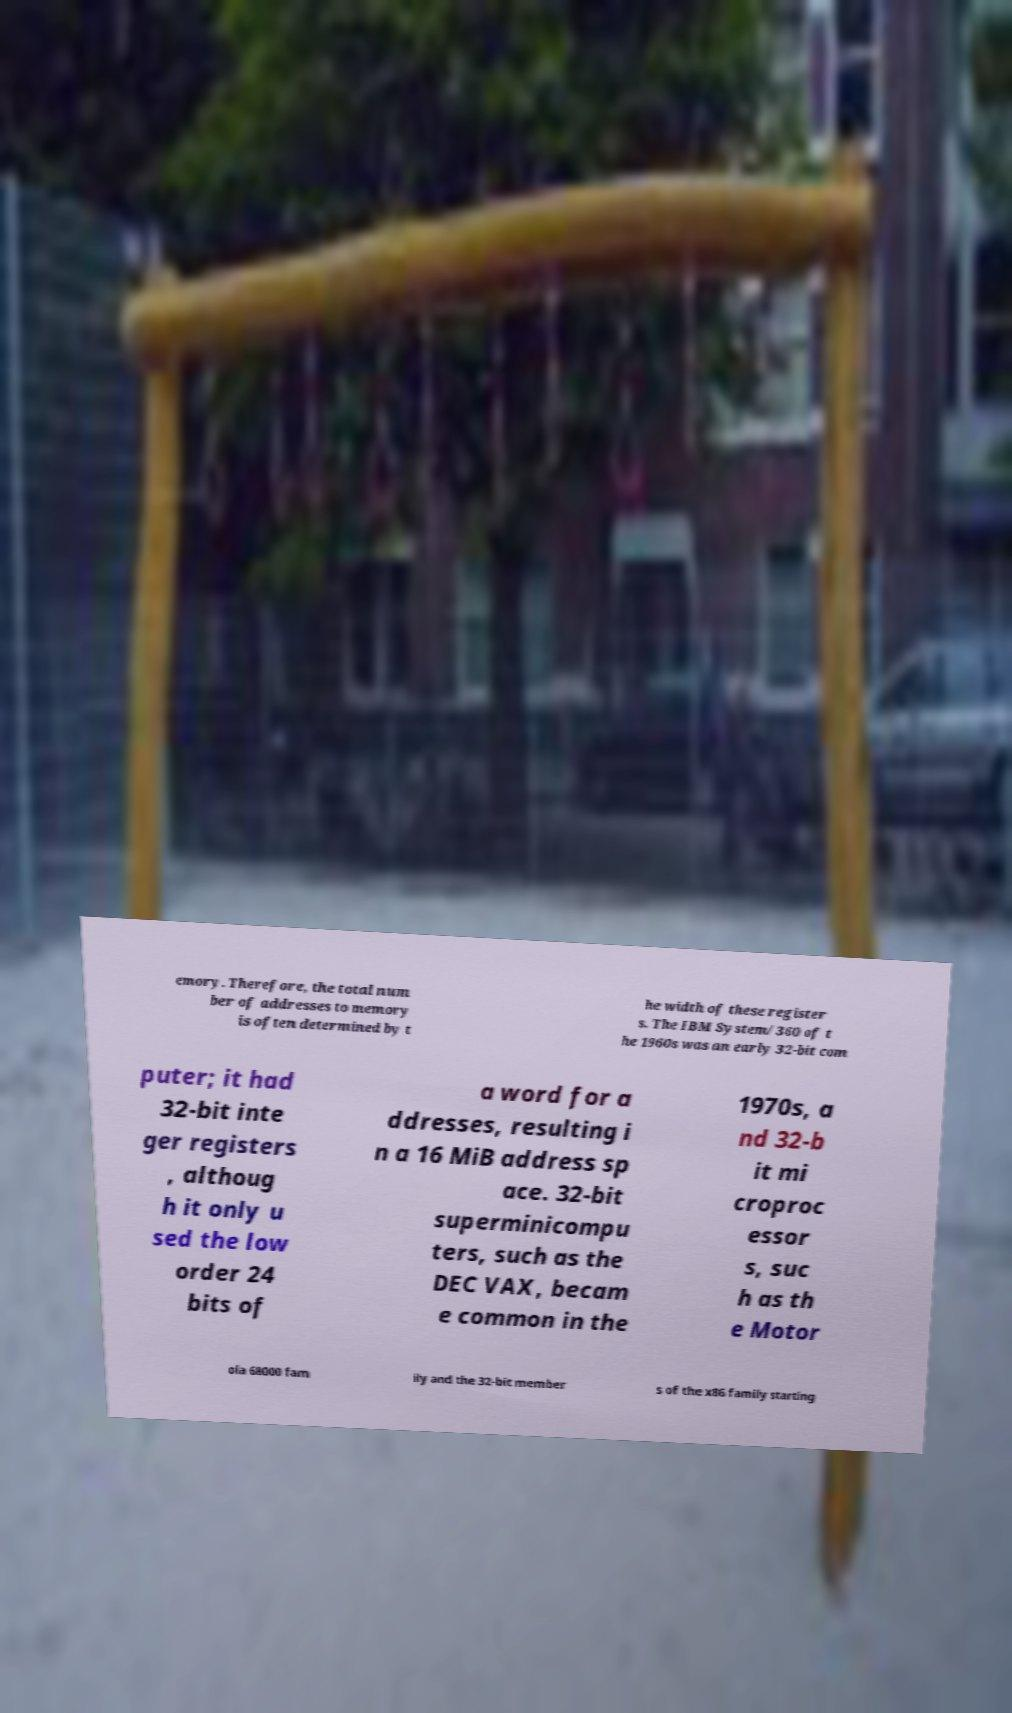Could you extract and type out the text from this image? emory. Therefore, the total num ber of addresses to memory is often determined by t he width of these register s. The IBM System/360 of t he 1960s was an early 32-bit com puter; it had 32-bit inte ger registers , althoug h it only u sed the low order 24 bits of a word for a ddresses, resulting i n a 16 MiB address sp ace. 32-bit superminicompu ters, such as the DEC VAX, becam e common in the 1970s, a nd 32-b it mi croproc essor s, suc h as th e Motor ola 68000 fam ily and the 32-bit member s of the x86 family starting 